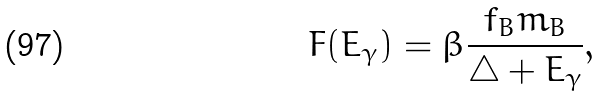<formula> <loc_0><loc_0><loc_500><loc_500>F ( E _ { \gamma } ) = \beta \frac { f _ { B } m _ { B } } { \bigtriangleup + E _ { \gamma } } ,</formula> 